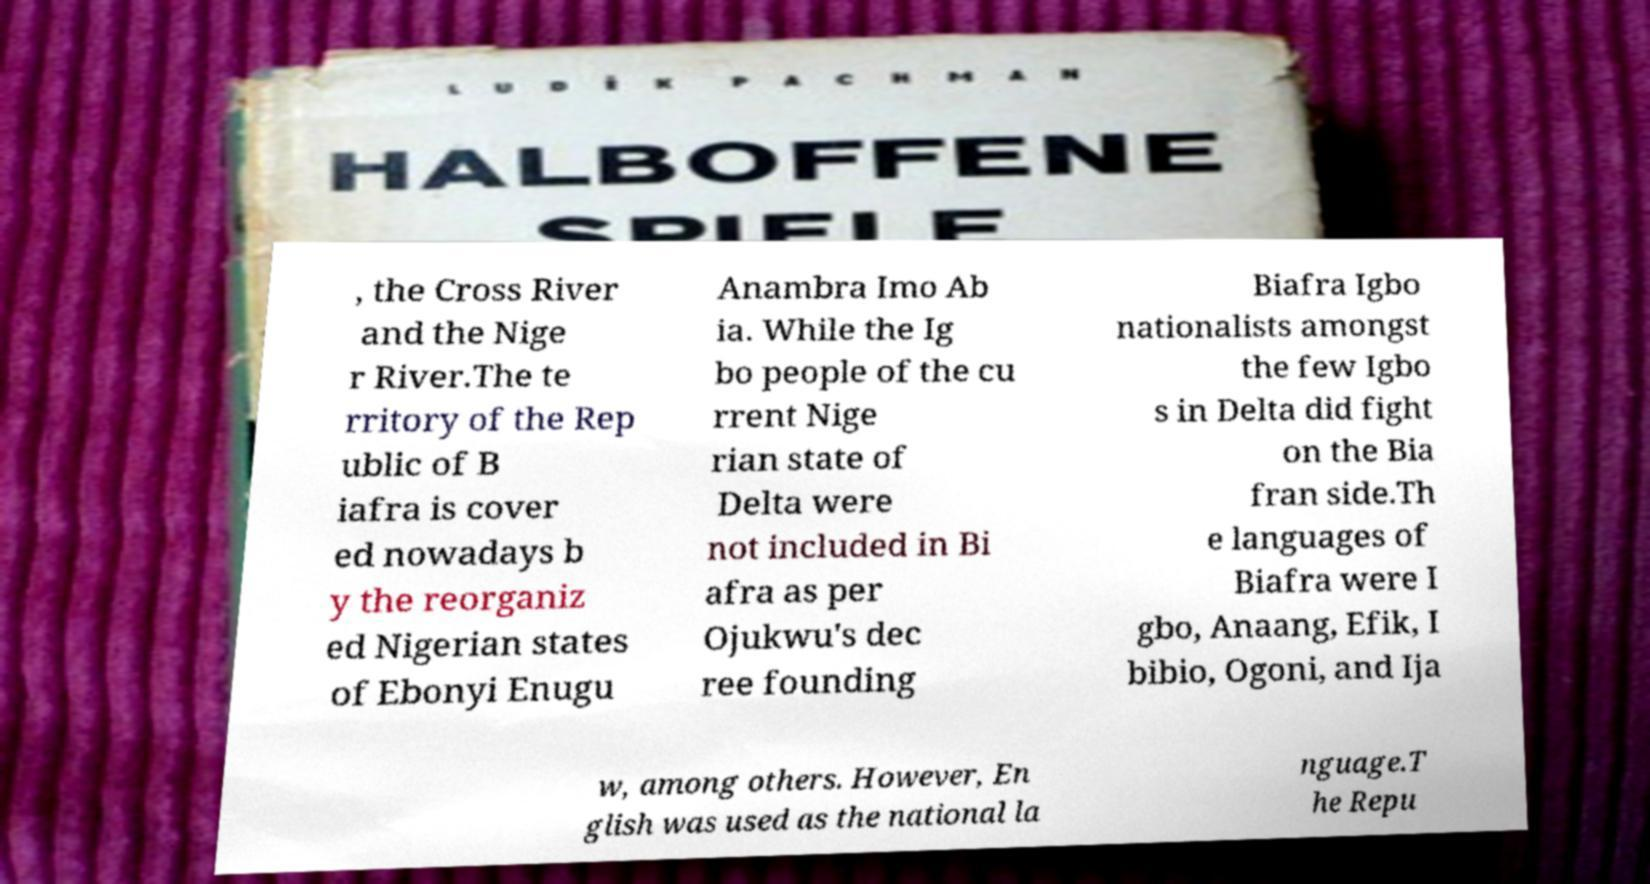For documentation purposes, I need the text within this image transcribed. Could you provide that? , the Cross River and the Nige r River.The te rritory of the Rep ublic of B iafra is cover ed nowadays b y the reorganiz ed Nigerian states of Ebonyi Enugu Anambra Imo Ab ia. While the Ig bo people of the cu rrent Nige rian state of Delta were not included in Bi afra as per Ojukwu's dec ree founding Biafra Igbo nationalists amongst the few Igbo s in Delta did fight on the Bia fran side.Th e languages of Biafra were I gbo, Anaang, Efik, I bibio, Ogoni, and Ija w, among others. However, En glish was used as the national la nguage.T he Repu 